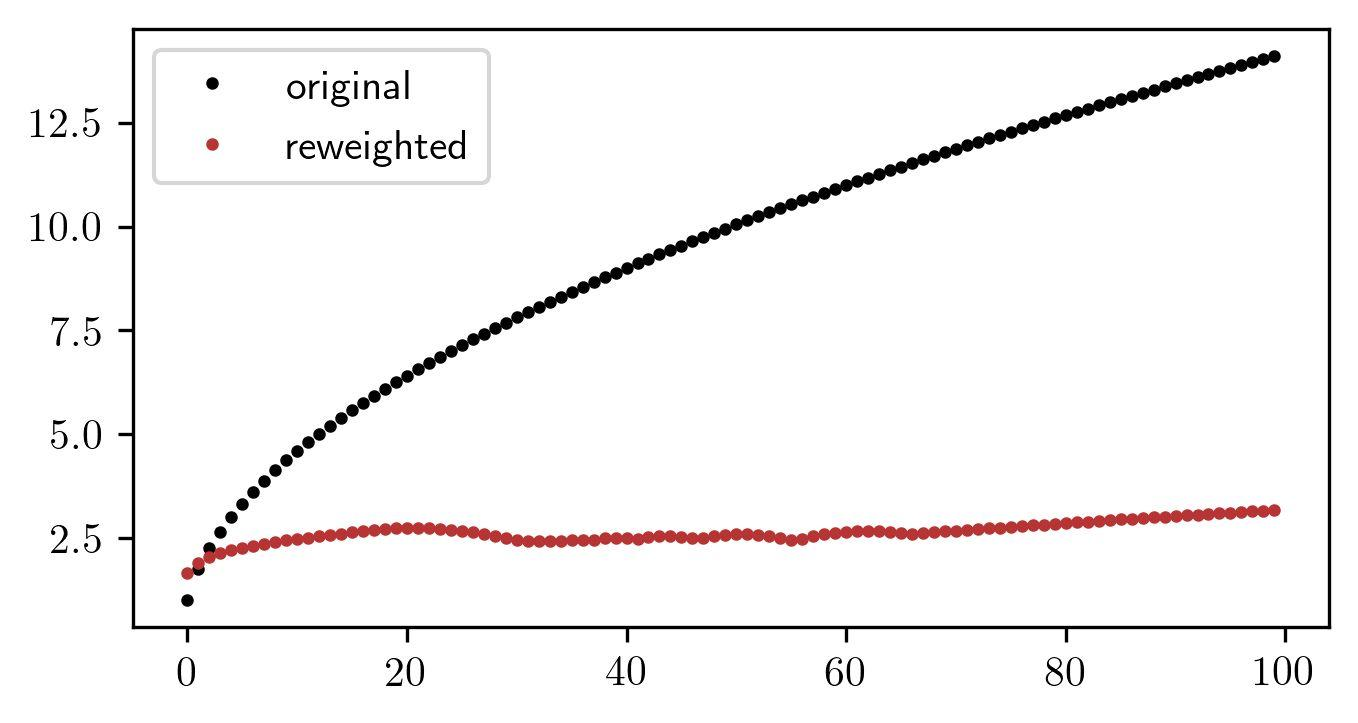What might the x-axis in the graph represent given the spread of the original and reweighted data points? Although the image does not provide specific labels for the axes, one possibility is that the x-axis could represent time or the progression of a certain variable, with the original data points increasing steadily. This type of trend is often observed in cumulative data such as growth over time or accumulating measurements. On the other hand, the reweighted data points might represent adjusted values accounting for certain conditions or corrections applied to the original data, thereby not showing an increased trend but rather a stabilizing effect around a certain level, which is approximately 2.5 on the y-axis. 